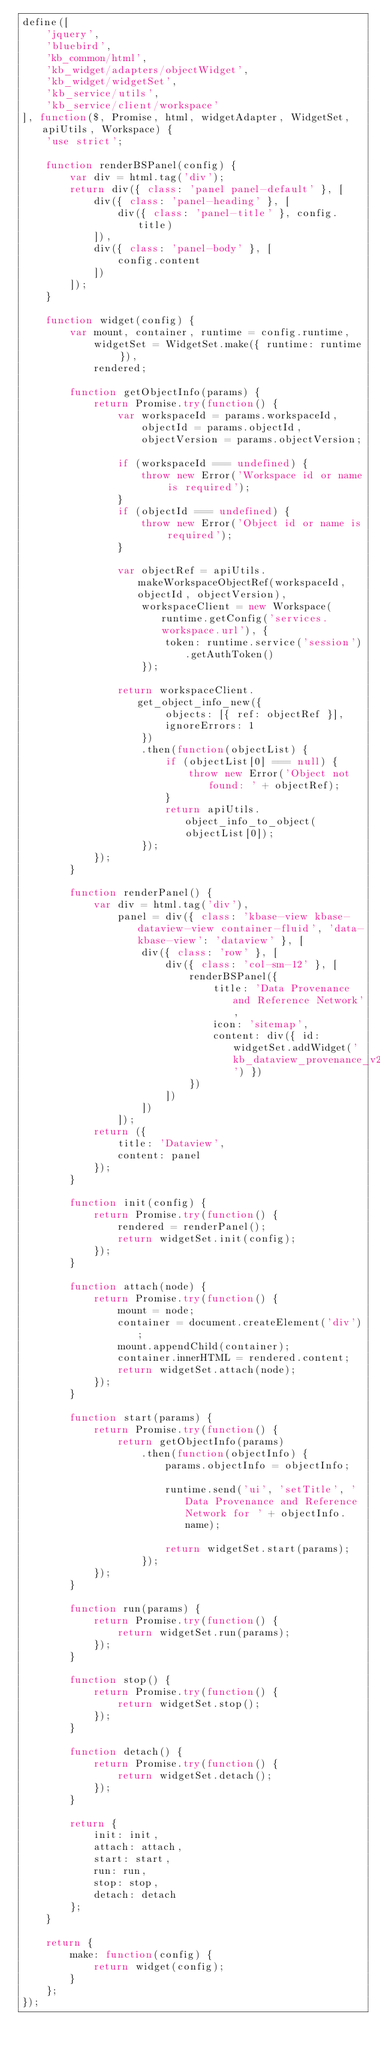<code> <loc_0><loc_0><loc_500><loc_500><_JavaScript_>define([
    'jquery',
    'bluebird',
    'kb_common/html',
    'kb_widget/adapters/objectWidget',
    'kb_widget/widgetSet',
    'kb_service/utils',
    'kb_service/client/workspace'
], function($, Promise, html, widgetAdapter, WidgetSet, apiUtils, Workspace) {
    'use strict';

    function renderBSPanel(config) {
        var div = html.tag('div');
        return div({ class: 'panel panel-default' }, [
            div({ class: 'panel-heading' }, [
                div({ class: 'panel-title' }, config.title)
            ]),
            div({ class: 'panel-body' }, [
                config.content
            ])
        ]);
    }

    function widget(config) {
        var mount, container, runtime = config.runtime,
            widgetSet = WidgetSet.make({ runtime: runtime }),
            rendered;

        function getObjectInfo(params) {
            return Promise.try(function() {
                var workspaceId = params.workspaceId,
                    objectId = params.objectId,
                    objectVersion = params.objectVersion;

                if (workspaceId === undefined) {
                    throw new Error('Workspace id or name is required');
                }
                if (objectId === undefined) {
                    throw new Error('Object id or name is required');
                }

                var objectRef = apiUtils.makeWorkspaceObjectRef(workspaceId, objectId, objectVersion),
                    workspaceClient = new Workspace(runtime.getConfig('services.workspace.url'), {
                        token: runtime.service('session').getAuthToken()
                    });

                return workspaceClient.get_object_info_new({
                        objects: [{ ref: objectRef }],
                        ignoreErrors: 1
                    })
                    .then(function(objectList) {
                        if (objectList[0] === null) {
                            throw new Error('Object not found: ' + objectRef);
                        }
                        return apiUtils.object_info_to_object(objectList[0]);
                    });
            });
        }

        function renderPanel() {
            var div = html.tag('div'),
                panel = div({ class: 'kbase-view kbase-dataview-view container-fluid', 'data-kbase-view': 'dataview' }, [
                    div({ class: 'row' }, [
                        div({ class: 'col-sm-12' }, [
                            renderBSPanel({
                                title: 'Data Provenance and Reference Network',
                                icon: 'sitemap',
                                content: div({ id: widgetSet.addWidget('kb_dataview_provenance_v2') })
                            })
                        ])
                    ])
                ]);
            return ({
                title: 'Dataview',
                content: panel
            });
        }

        function init(config) {
            return Promise.try(function() {
                rendered = renderPanel();
                return widgetSet.init(config);
            });
        }

        function attach(node) {
            return Promise.try(function() {
                mount = node;
                container = document.createElement('div');
                mount.appendChild(container);
                container.innerHTML = rendered.content;
                return widgetSet.attach(node);
            });
        }

        function start(params) {
            return Promise.try(function() {
                return getObjectInfo(params)
                    .then(function(objectInfo) {
                        params.objectInfo = objectInfo;

                        runtime.send('ui', 'setTitle', 'Data Provenance and Reference Network for ' + objectInfo.name);

                        return widgetSet.start(params);
                    });
            });
        }

        function run(params) {
            return Promise.try(function() {
                return widgetSet.run(params);
            });
        }

        function stop() {
            return Promise.try(function() {
                return widgetSet.stop();
            });
        }

        function detach() {
            return Promise.try(function() {
                return widgetSet.detach();
            });
        }

        return {
            init: init,
            attach: attach,
            start: start,
            run: run,
            stop: stop,
            detach: detach
        };
    }

    return {
        make: function(config) {
            return widget(config);
        }
    };
});</code> 